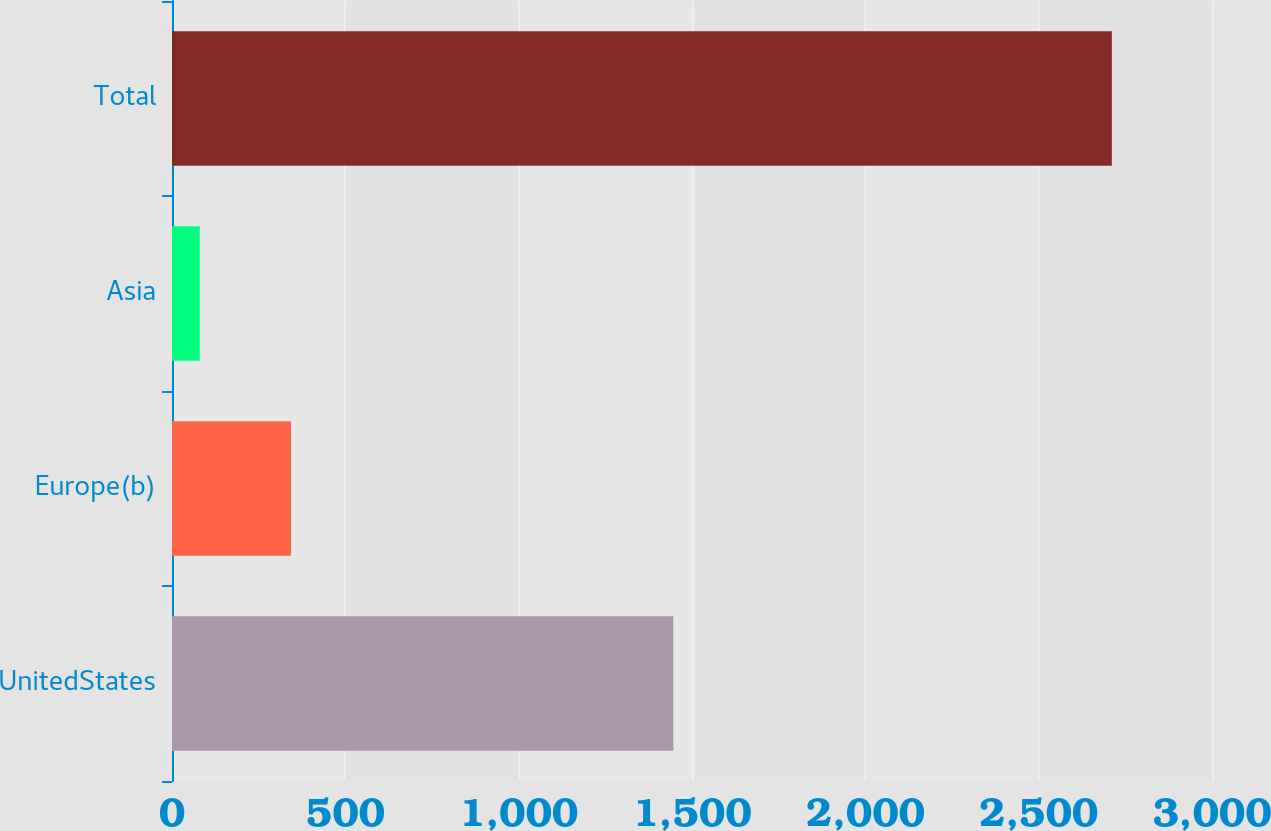Convert chart to OTSL. <chart><loc_0><loc_0><loc_500><loc_500><bar_chart><fcel>UnitedStates<fcel>Europe(b)<fcel>Asia<fcel>Total<nl><fcel>1446<fcel>343.1<fcel>80<fcel>2711<nl></chart> 